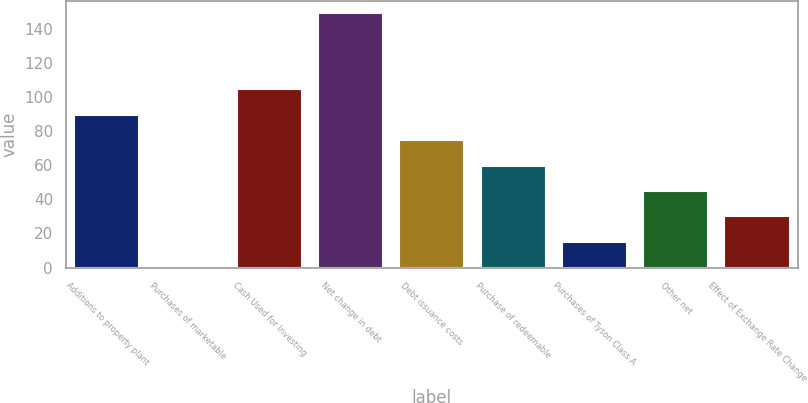Convert chart. <chart><loc_0><loc_0><loc_500><loc_500><bar_chart><fcel>Additions to property plant<fcel>Purchases of marketable<fcel>Cash Used for Investing<fcel>Net change in debt<fcel>Debt issuance costs<fcel>Purchase of redeemable<fcel>Purchases of Tyson Class A<fcel>Other net<fcel>Effect of Exchange Rate Change<nl><fcel>89.52<fcel>0.3<fcel>104.39<fcel>149<fcel>74.65<fcel>59.78<fcel>15.17<fcel>44.91<fcel>30.04<nl></chart> 